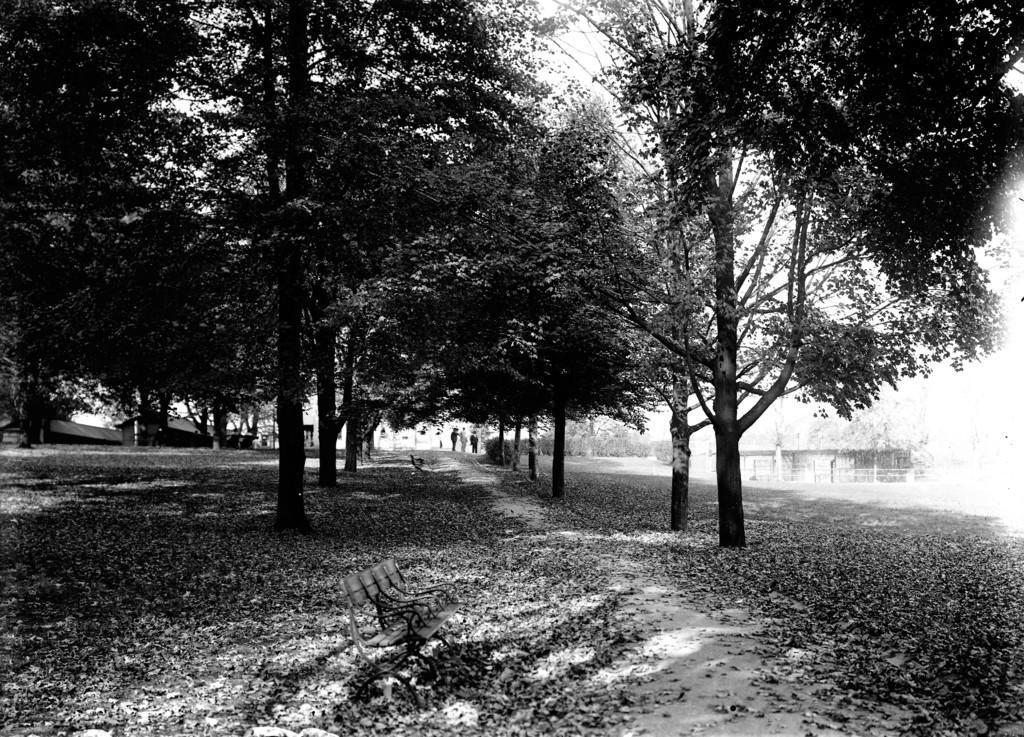Please provide a concise description of this image. This is a black and white image and here we can see trees, sheds and there are some people and there are benches. At the bottom, there are leaves on the ground. 